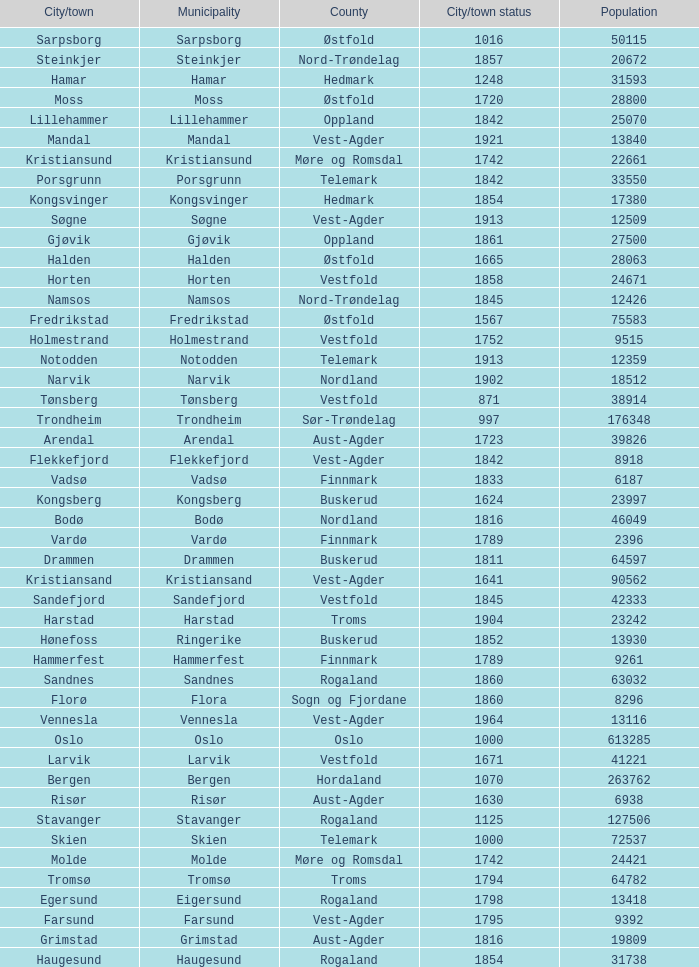What is the total population in the city/town of Arendal? 1.0. 